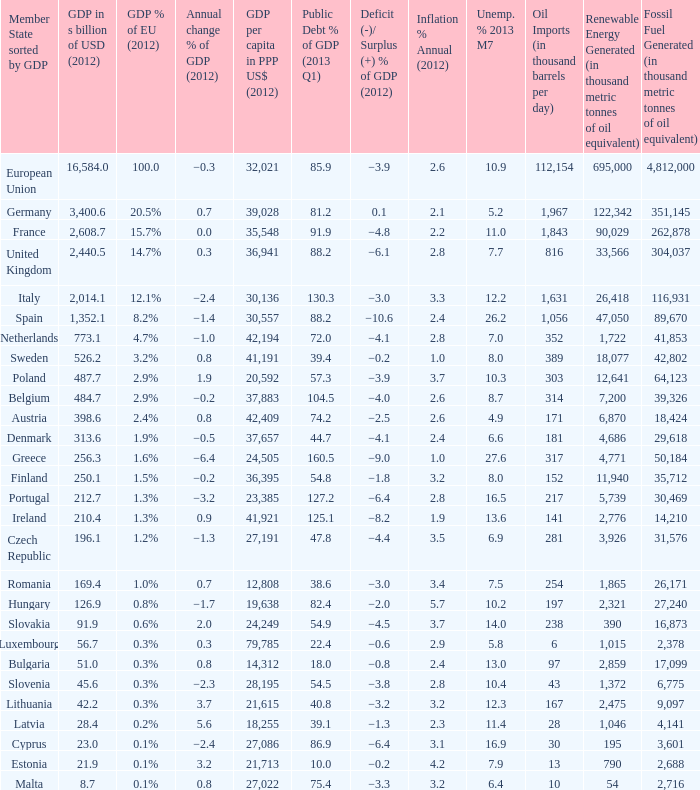What is the average public debt % of GDP in 2013 Q1 of the country with a member slate sorted by GDP of Czech Republic and a GDP per capita in PPP US dollars in 2012 greater than 27,191? None. 